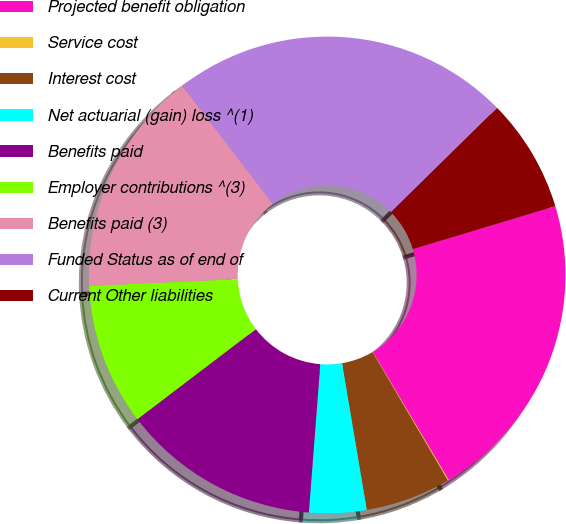<chart> <loc_0><loc_0><loc_500><loc_500><pie_chart><fcel>Projected benefit obligation<fcel>Service cost<fcel>Interest cost<fcel>Net actuarial (gain) loss ^(1)<fcel>Benefits paid<fcel>Employer contributions ^(3)<fcel>Benefits paid (3)<fcel>Funded Status as of end of<fcel>Current Other liabilities<nl><fcel>21.14%<fcel>0.07%<fcel>5.79%<fcel>3.88%<fcel>13.43%<fcel>9.61%<fcel>15.34%<fcel>23.04%<fcel>7.7%<nl></chart> 